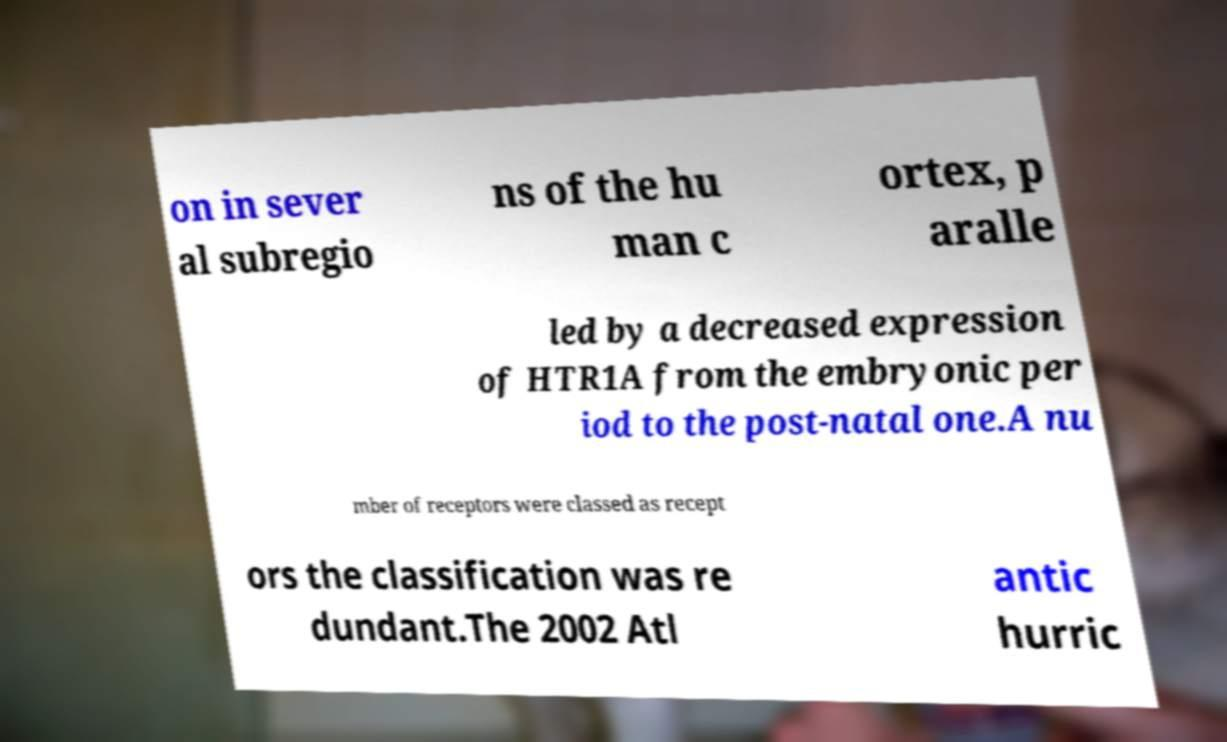Could you extract and type out the text from this image? on in sever al subregio ns of the hu man c ortex, p aralle led by a decreased expression of HTR1A from the embryonic per iod to the post-natal one.A nu mber of receptors were classed as recept ors the classification was re dundant.The 2002 Atl antic hurric 